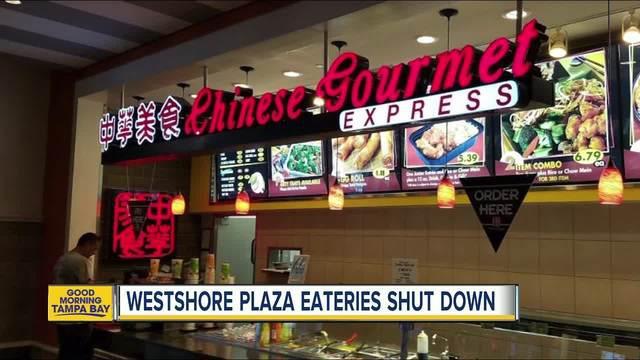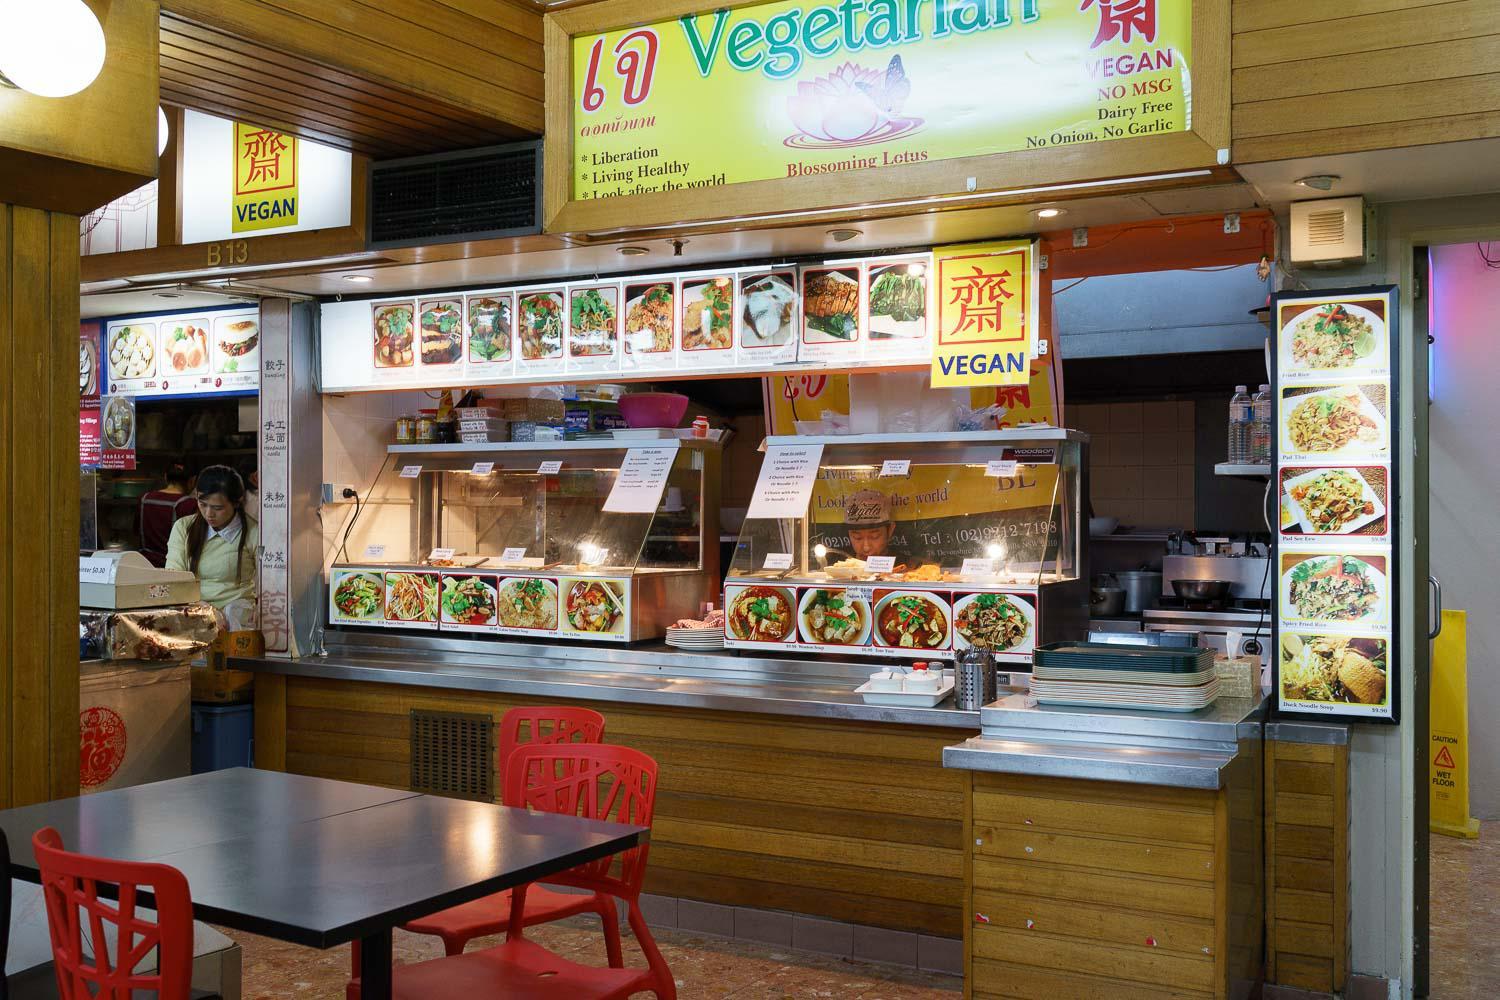The first image is the image on the left, the second image is the image on the right. Given the left and right images, does the statement "An unoccupied table sits near a restaurant in one of the images." hold true? Answer yes or no. Yes. The first image is the image on the left, the second image is the image on the right. Examine the images to the left and right. Is the description "The lights in the image on the left are hanging above the counter." accurate? Answer yes or no. Yes. 